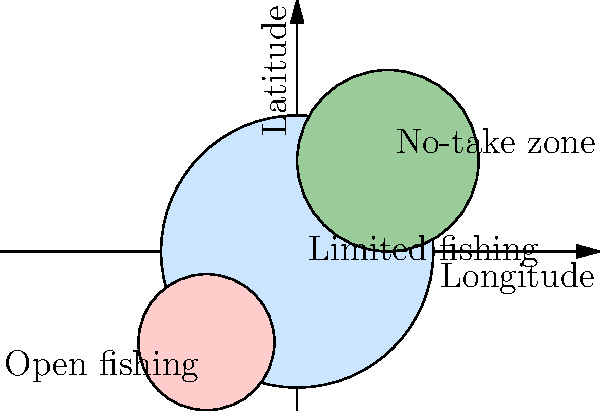Based on the map of marine protected areas shown above, which zone is likely to have the highest fish biomass and biodiversity, and why would this information be crucial for local marine policy decisions? To answer this question, we need to analyze the different zones in the marine protected area map and understand their implications:

1. The map shows three distinct zones:
   a) No-take zone (green)
   b) Limited fishing zone (light blue)
   c) Open fishing zone (pink)

2. Fish biomass and biodiversity are typically highest in no-take zones:
   a) No-take zones prohibit all extractive activities, including fishing.
   b) This allows fish populations to recover and grow without human interference.
   c) Over time, this leads to larger and more diverse fish populations.

3. Limited fishing zones offer some protection:
   a) These areas have restrictions on fishing activities but are not fully protected.
   b) They can serve as a buffer between no-take zones and open fishing areas.
   c) Fish biomass and biodiversity are likely to be higher than in open fishing zones but lower than in no-take zones.

4. Open fishing zones have the least protection:
   a) These areas allow unrestricted fishing activities.
   b) They typically have lower fish biomass and biodiversity due to continuous exploitation.

5. Importance for local marine policy decisions:
   a) Understanding the effectiveness of different protection levels helps in designing effective marine protected areas.
   b) It allows policymakers to balance conservation goals with the needs of local fishing communities.
   c) Data on fish biomass and biodiversity can be used to justify the expansion or modification of existing protected areas.
   d) It provides evidence for the benefits of no-take zones in marine conservation efforts.
   e) This information can be used to educate stakeholders and gain support for marine protection measures.

Therefore, the no-take zone (green) is likely to have the highest fish biomass and biodiversity. This information is crucial for local marine policy decisions as it provides evidence for the effectiveness of different protection levels and helps balance conservation goals with socio-economic needs.
Answer: No-take zone; informs effective policy balancing conservation and socio-economic needs. 